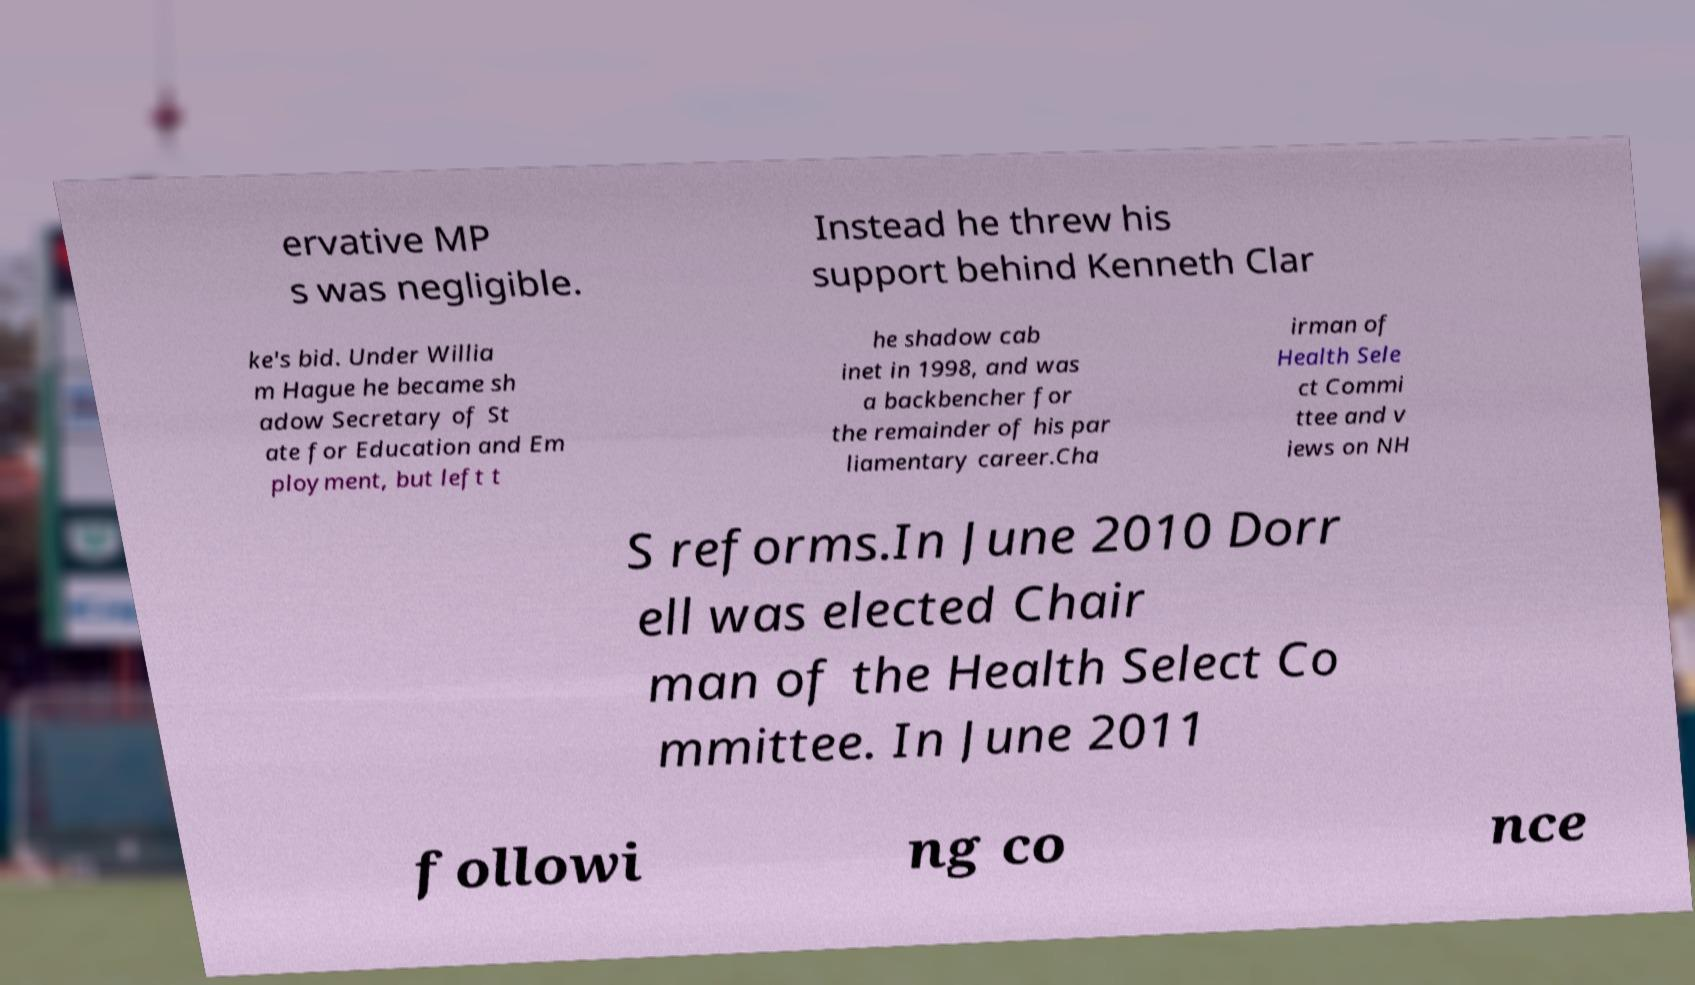Could you extract and type out the text from this image? ervative MP s was negligible. Instead he threw his support behind Kenneth Clar ke's bid. Under Willia m Hague he became sh adow Secretary of St ate for Education and Em ployment, but left t he shadow cab inet in 1998, and was a backbencher for the remainder of his par liamentary career.Cha irman of Health Sele ct Commi ttee and v iews on NH S reforms.In June 2010 Dorr ell was elected Chair man of the Health Select Co mmittee. In June 2011 followi ng co nce 